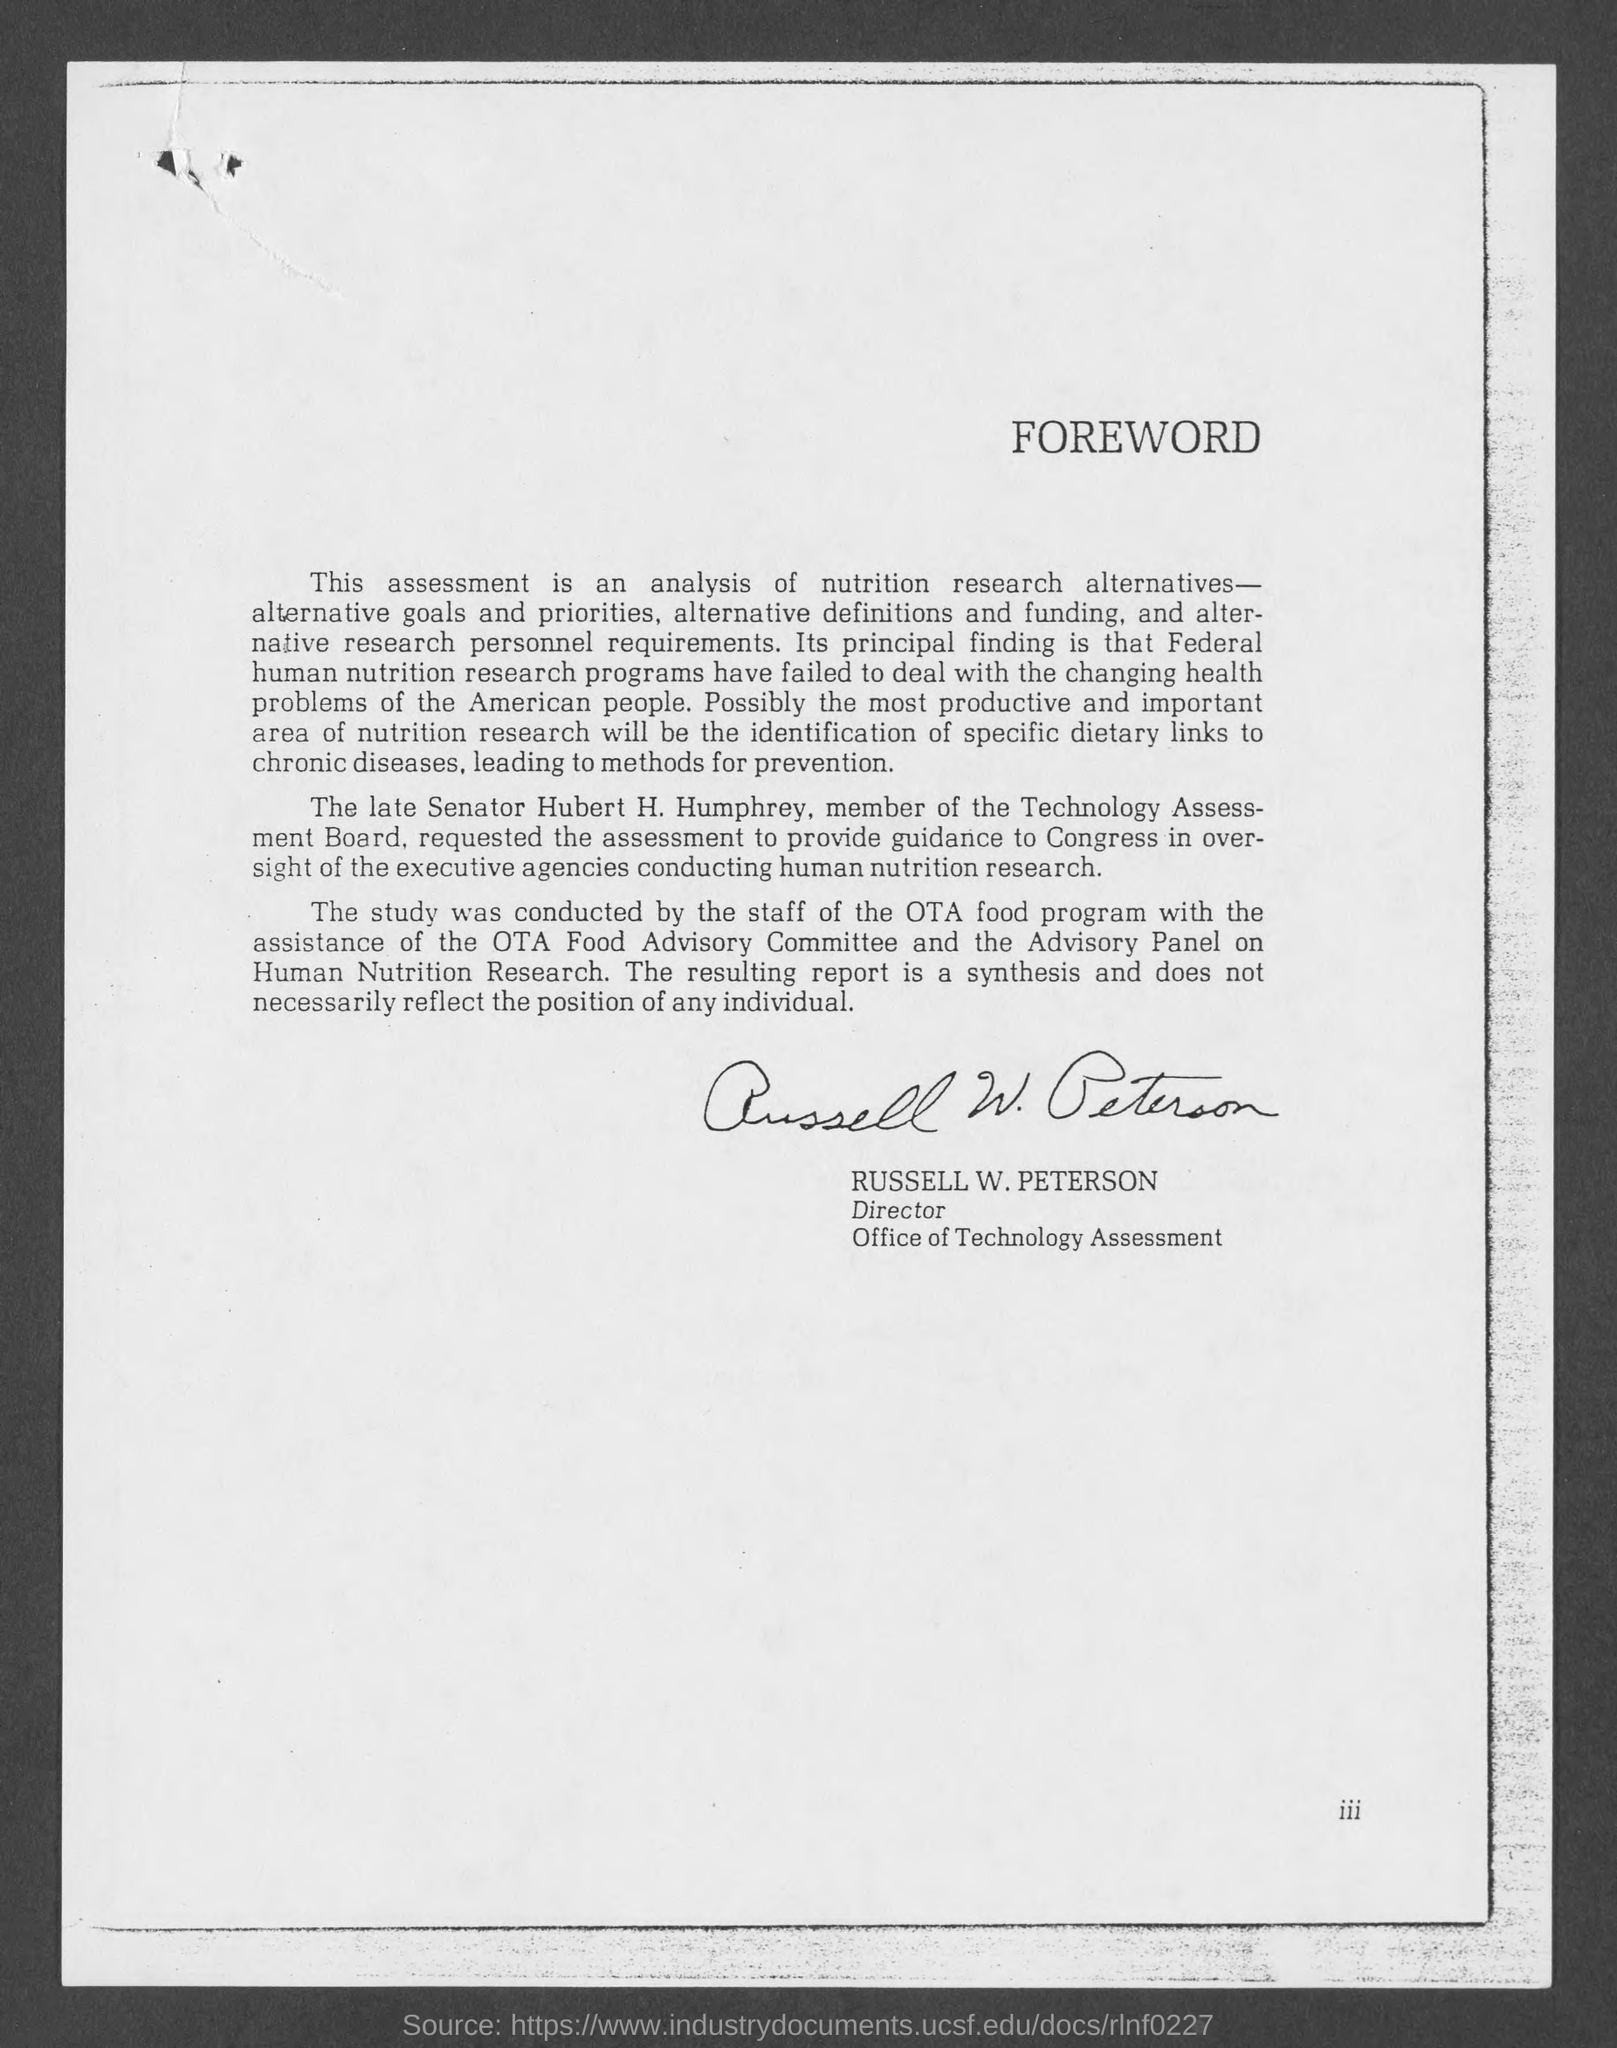Who has signed this document?
Offer a terse response. RUSSELL W. PETERSON. 